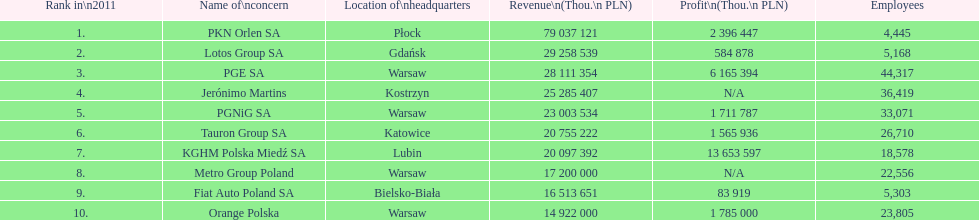Which company had the most employees? PGE SA. 